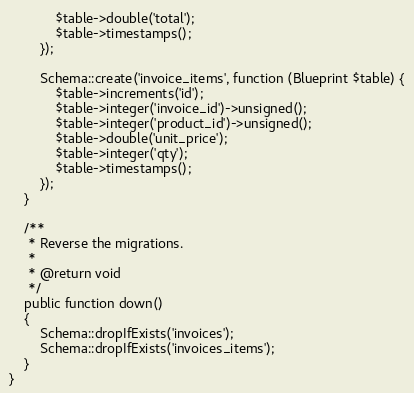<code> <loc_0><loc_0><loc_500><loc_500><_PHP_>            $table->double('total');
            $table->timestamps();
        });

        Schema::create('invoice_items', function (Blueprint $table) {
            $table->increments('id');
            $table->integer('invoice_id')->unsigned();
            $table->integer('product_id')->unsigned();
            $table->double('unit_price');
            $table->integer('qty');
            $table->timestamps();
        });
    }

    /**
     * Reverse the migrations.
     *
     * @return void
     */
    public function down()
    {
        Schema::dropIfExists('invoices');
        Schema::dropIfExists('invoices_items');
    }
}
</code> 